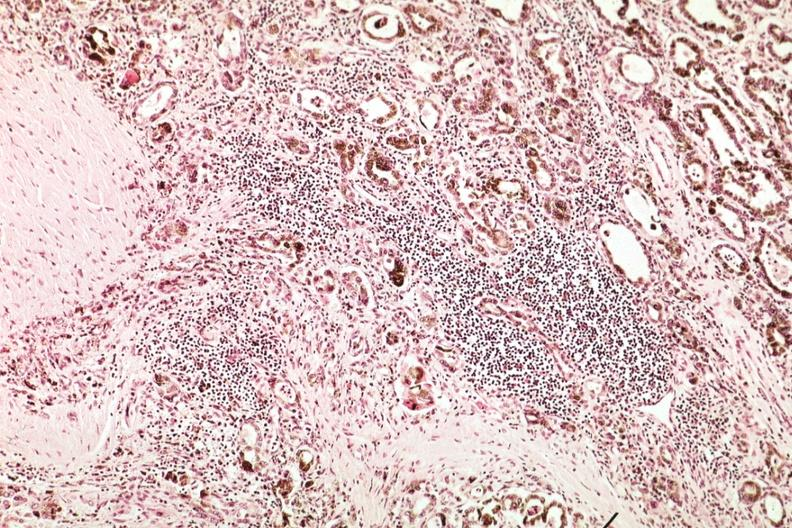does this image show marked atrophy with iron in epithelium and lymphocytic infiltrate?
Answer the question using a single word or phrase. Yes 